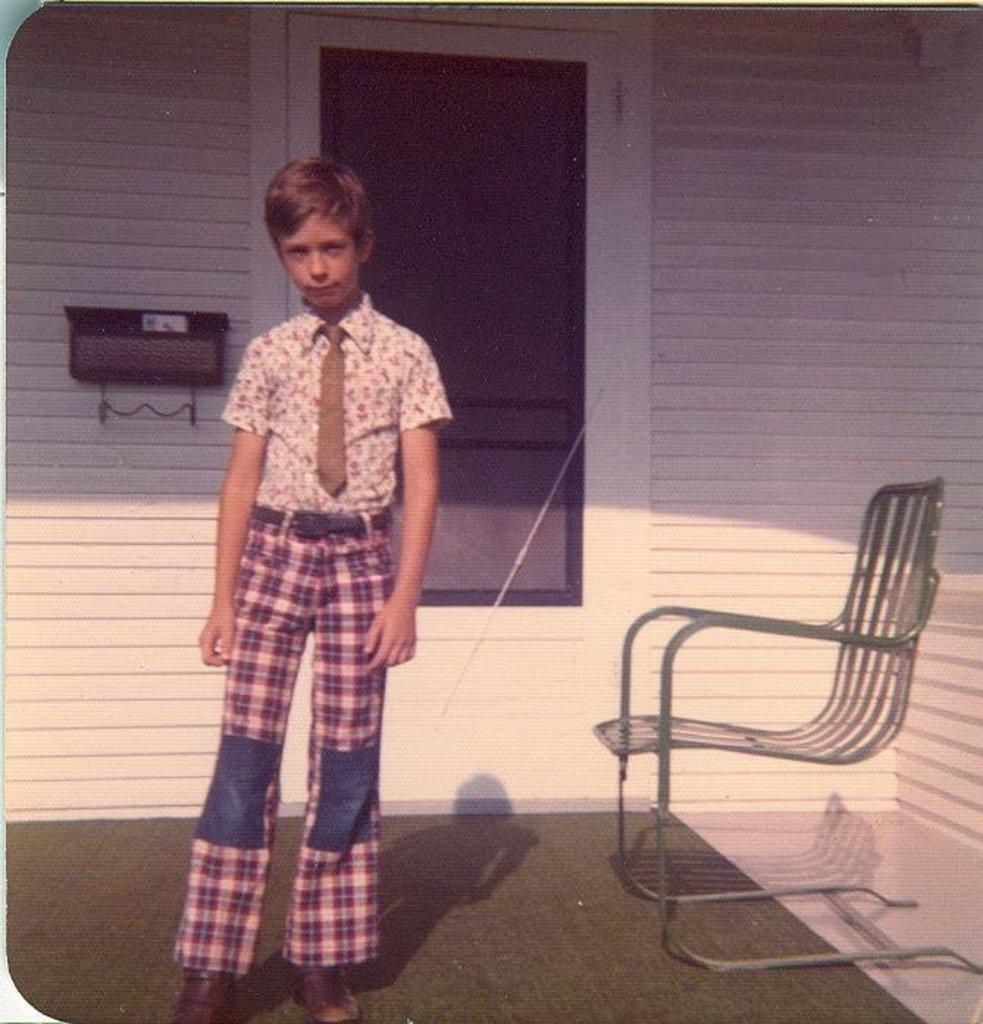Who is present in the image? There is a boy in the image. What is the boy standing on? The boy is standing on a carpet. What can be seen in the background of the image? There is a chair, a door, and a wall in the background of the image. What type of needle is the boy using to sew a ship in the image? There is no needle or ship present in the image; it only features a boy standing on a carpet with a chair, door, and wall in the background. 